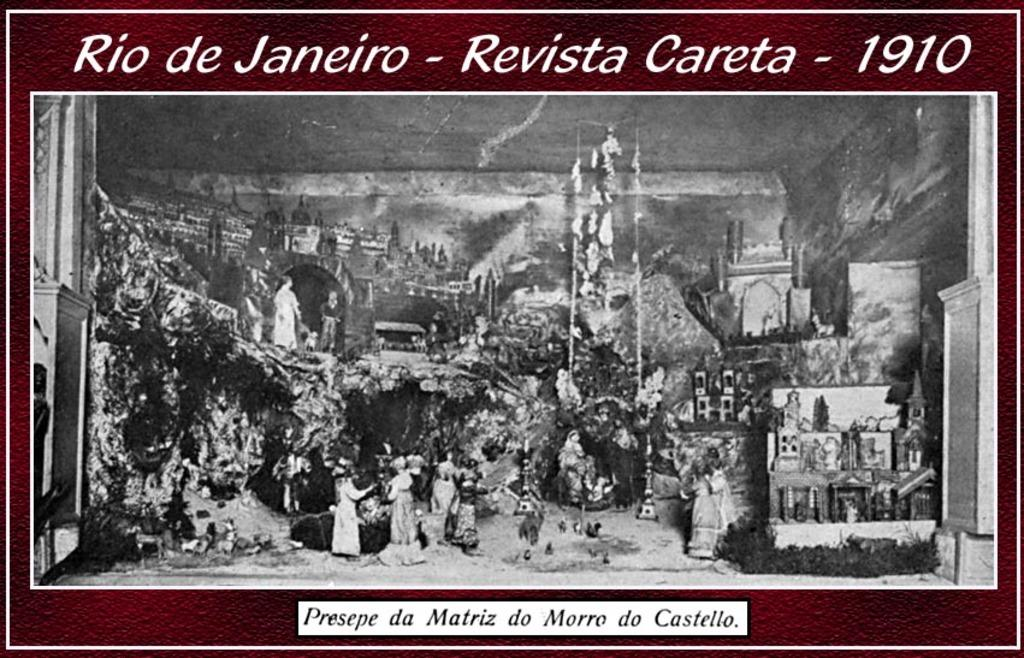What type of item is in the image? There is an old photo in the image. What can be seen on the old photo? The old photo has writing on it. What does the writing on the photo say? The writing on the photo says "Rio de Janeiro revista Careta 1910". What type of cracker is featured in the old photo? There is no cracker present in the image; it is an old photo with writing on it. Is there a carpenter working on a tray in the old photo? There is no carpenter or tray present in the image; it is an old photo with writing on it. 